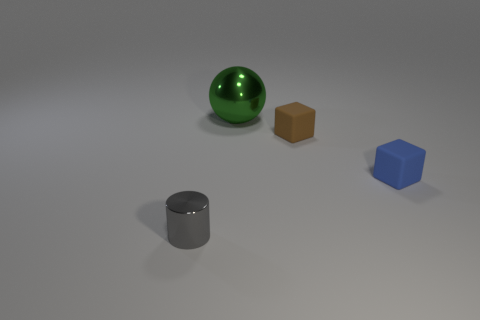Is the material of the large sphere the same as the object that is to the left of the big metal ball?
Ensure brevity in your answer.  Yes. There is a brown block that is the same material as the tiny blue block; what size is it?
Make the answer very short. Small. What is the size of the shiny object on the right side of the gray cylinder?
Give a very brief answer. Large. How many brown rubber blocks have the same size as the gray shiny thing?
Your answer should be very brief. 1. Are there any matte blocks of the same color as the sphere?
Make the answer very short. No. There is another cube that is the same size as the blue matte block; what color is it?
Offer a terse response. Brown. There is a cylinder; is it the same color as the rubber thing that is in front of the brown object?
Give a very brief answer. No. What is the color of the ball?
Provide a short and direct response. Green. There is a small thing that is left of the big green ball; what material is it?
Your answer should be very brief. Metal. There is a brown object that is the same shape as the blue matte thing; what size is it?
Offer a very short reply. Small. 